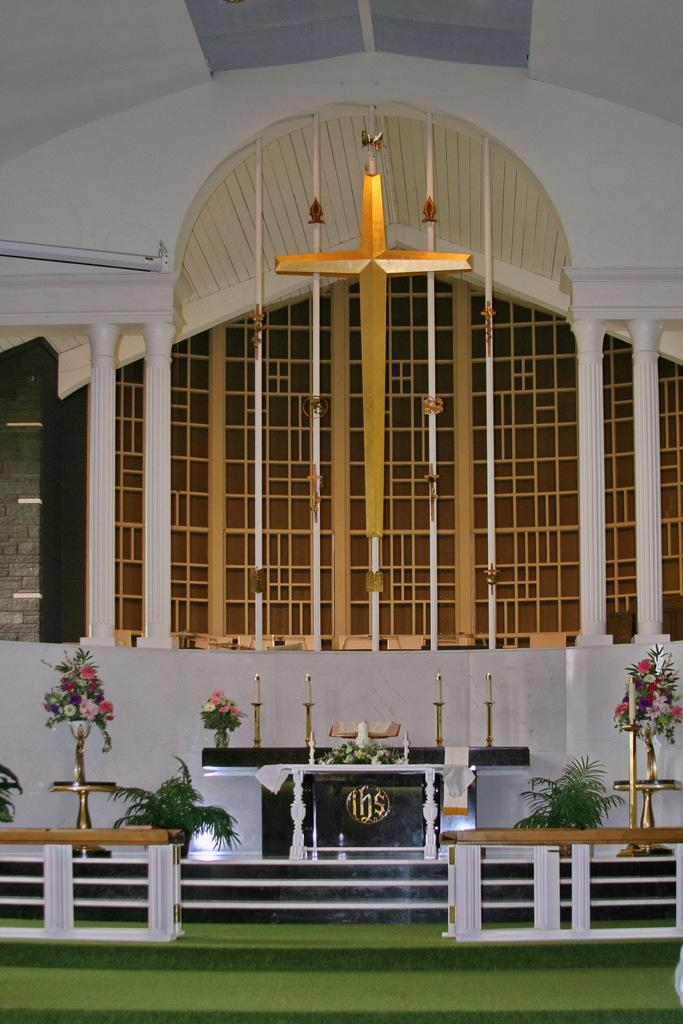What religious symbol can be seen in the image? There is a cross in the image. What architectural features are present in the image? There are pillars in the image. What decorative items are visible in the image? There are flower vases on stands and candles in the image. What can be seen in the background of the image? There is a wall visible in the background of the image. What type of humor can be found in the aftermath of the power outage in the image? There is no mention of a power outage or humor in the image; it features a cross, pillars, flower vases, candles, and a wall. 